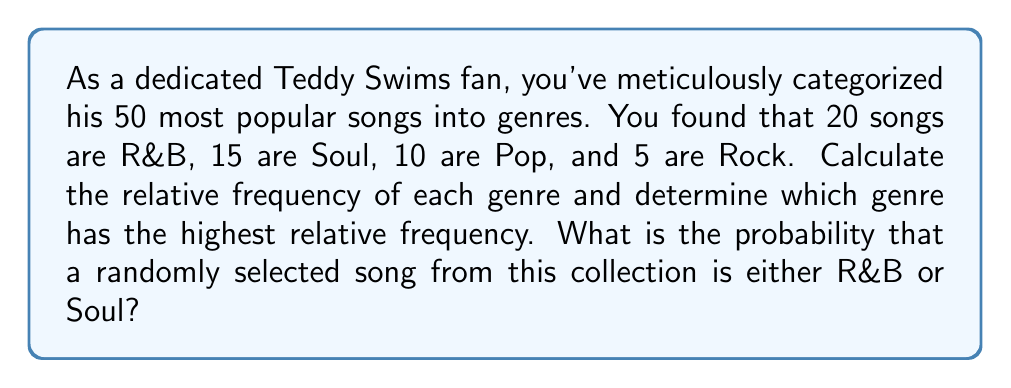Show me your answer to this math problem. To solve this problem, let's follow these steps:

1. Calculate the relative frequency for each genre:
   Relative frequency = Number of songs in the genre / Total number of songs

   R&B: $\frac{20}{50} = 0.40$ or $40\%$
   Soul: $\frac{15}{50} = 0.30$ or $30\%$
   Pop: $\frac{10}{50} = 0.20$ or $20\%$
   Rock: $\frac{5}{50} = 0.10$ or $10\%$

2. Determine the genre with the highest relative frequency:
   R&B has the highest relative frequency at 0.40 or 40%.

3. Calculate the probability of selecting either an R&B or Soul song:
   P(R&B or Soul) = P(R&B) + P(Soul)
   $$ P(\text{R&B or Soul}) = \frac{20}{50} + \frac{15}{50} = \frac{35}{50} = 0.70 $$

Therefore, the probability of randomly selecting either an R&B or Soul song from this collection is 0.70 or 70%.
Answer: 0.70 